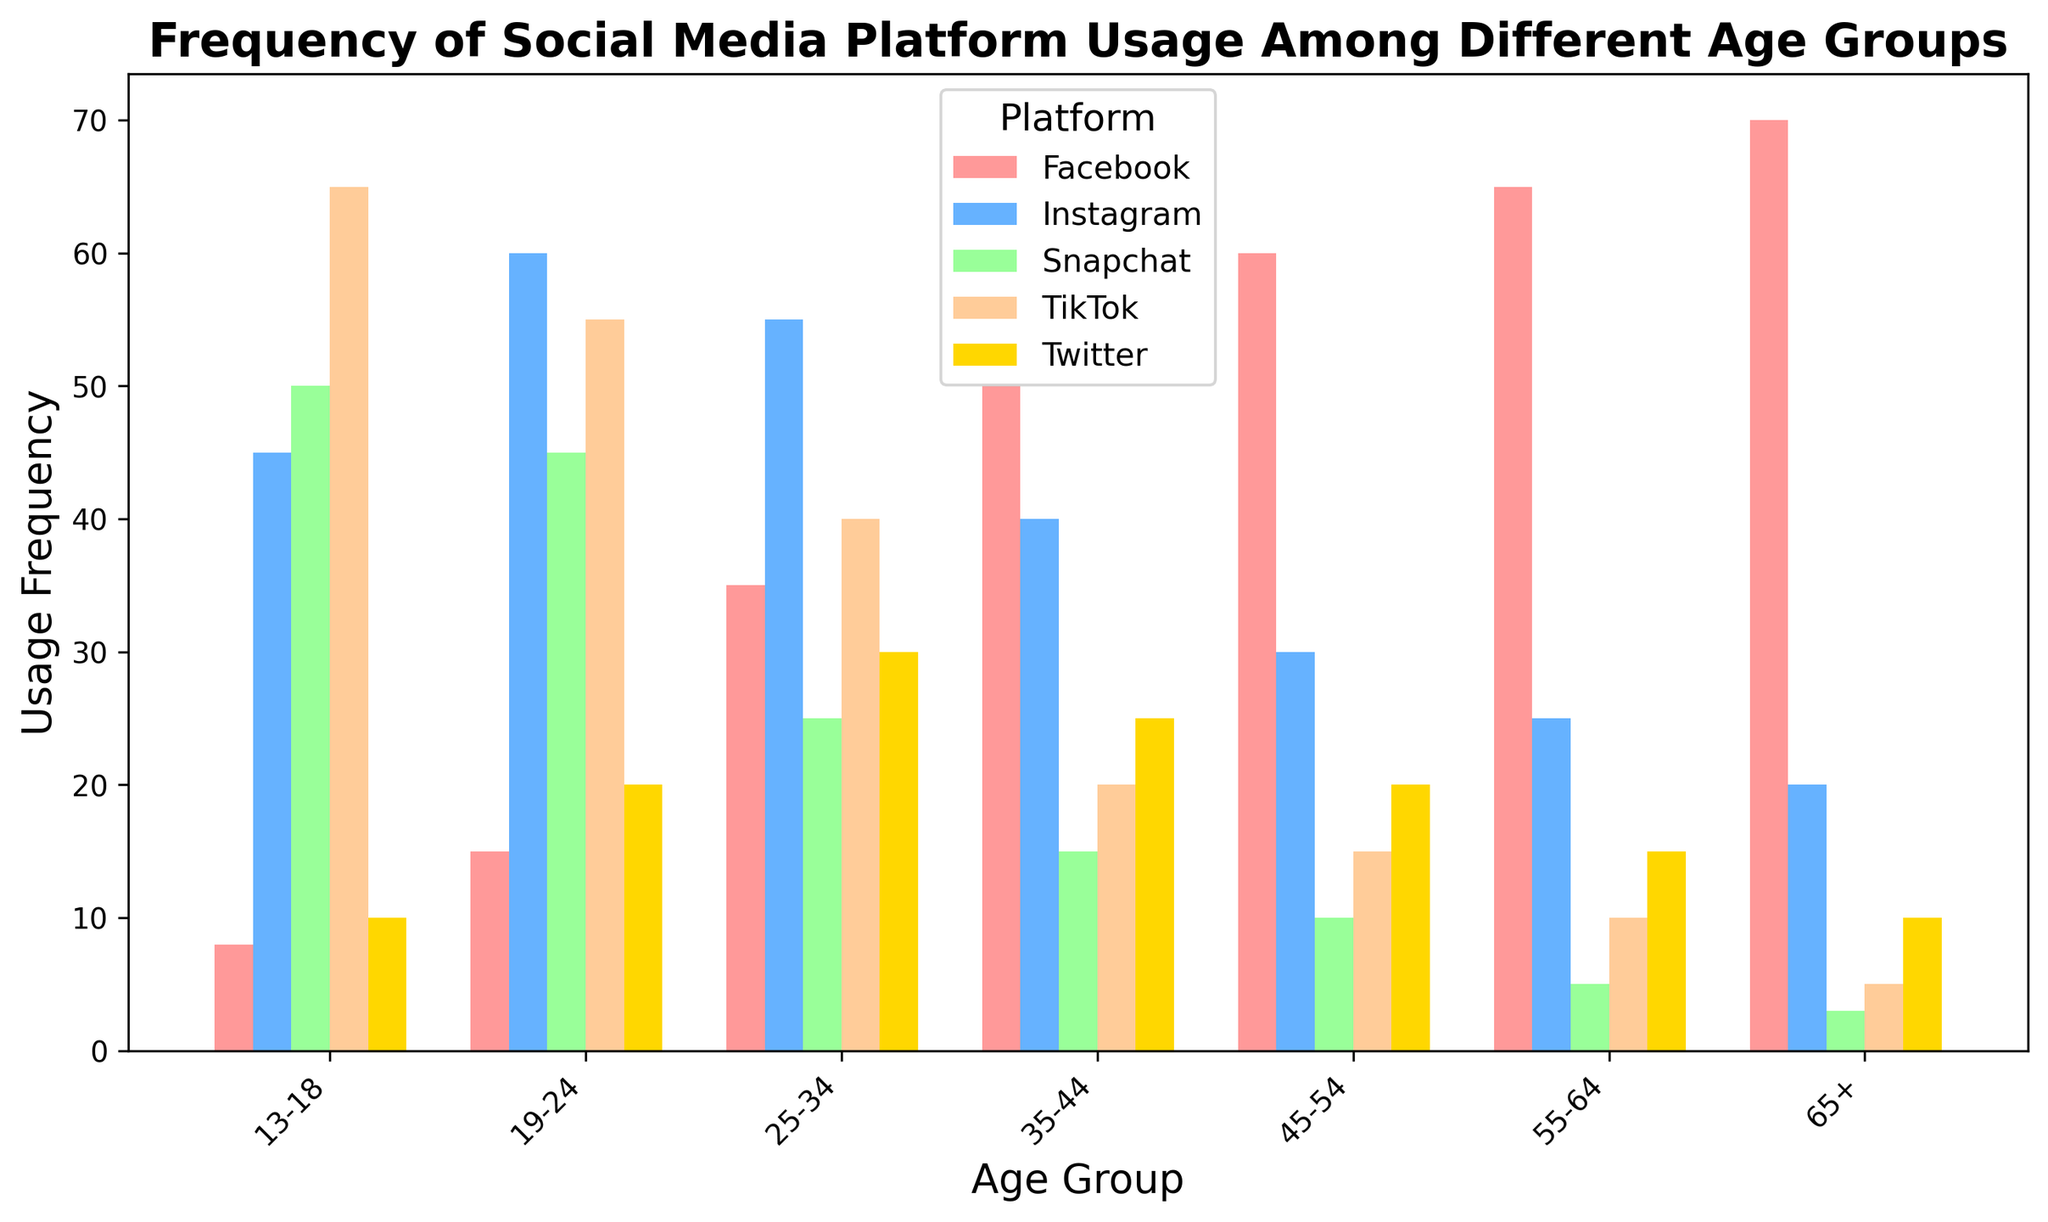What is the most frequently used social media platform for the 13-18 age group? Look at the bar heights for the 13-18 age group. The highest bar represents the usage frequency of TikTok, which is 65.
Answer: TikTok Which age group uses Facebook the most? Compare all the bars corresponding to Facebook for each age group. The highest bar is for the 65+ age group with a usage frequency of 70.
Answer: 65+ How much higher is Instagram usage than Twitter usage for the 19-24 age group? Identify the heights of the Instagram and Twitter bars for the 19-24 age group. Instagram is 60 and Twitter is 20, so the difference is 60 - 20 = 40.
Answer: 40 What is the total usage frequency of all social media platforms for the 45-54 age group? Sum the heights of all bars for the 45-54 age group: 60 (Facebook) + 30 (Instagram) + 20 (Twitter) + 10 (Snapchat) + 15 (TikTok) = 135.
Answer: 135 For the 35-44 age group, which platform has the lowest usage frequency, and what is the value? Examine all the bars for the 35-44 age group. The lowest bar is for Snapchat, with a usage frequency of 15.
Answer: Snapchat, 15 Across all age groups, which platform shows the most consistent usage (least variation in bar height)? Look at the bars for each platform across all age groups and observe their heights. Platforms with relatively similar heights across age groups are considered consistent. Facebook and Snapchat have more consistent heights compared to others.
Answer: Facebook or Snapchat How does the total usage frequency of TikTok compare between the 13-18 and 19-24 age groups? Identify the bar heights for TikTok in the 13-18 (65) and 19-24 (55) age groups. The difference is 65 - 55 = 10. So, TikTok usage is 10 higher in the younger age group.
Answer: Higher by 10 What is the average usage frequency of Instagram across all age groups? Sum the heights of all Instagram bars: 45 + 60 + 55 + 40 + 30 + 25 + 20 = 275. There are 7 age groups, so the average is 275 / 7 ≈ 39.29
Answer: Approximately 39.29 Which age group uses Twitter the least and by how much? Identify the lowest bar for Twitter across all age groups. The lowest usage is for the 55-64 and 65+ age groups, both with a usage frequency of 10.
Answer: 65+, 10 